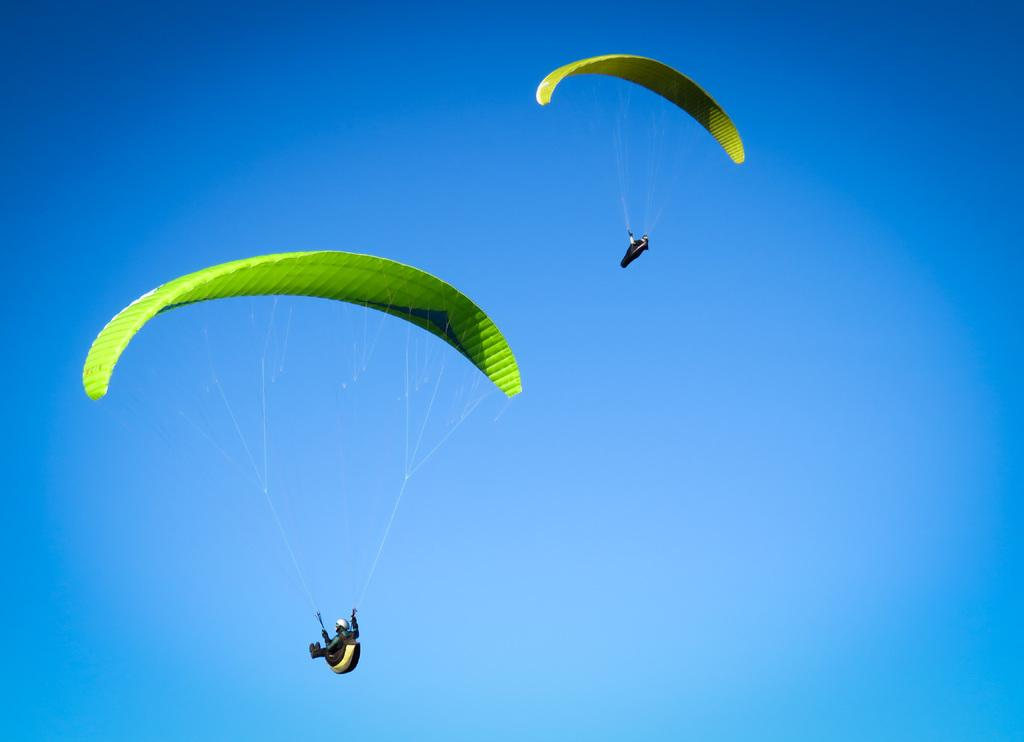What objects are in the air in the image? There are two parachutes in the air in the image. What color is the sky in the image? The sky is blue in the image. Where is the mark located in the image? There is no mark present in the image. What type of tool is being used by the person on the parachute? There are no people or tools visible in the image; only the parachutes and the blue sky are present. 